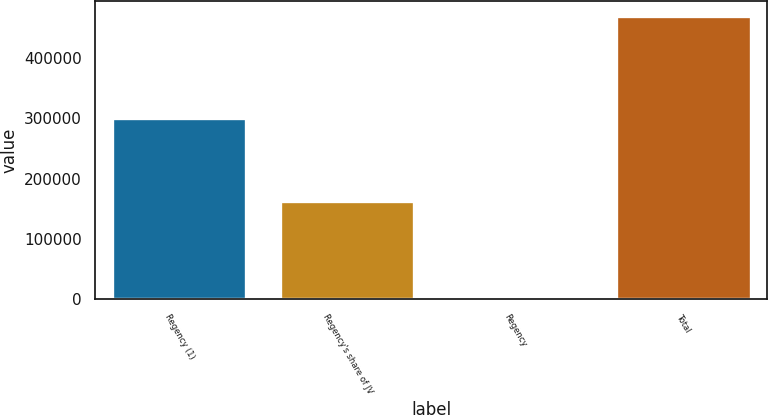Convert chart. <chart><loc_0><loc_0><loc_500><loc_500><bar_chart><fcel>Regency (1)<fcel>Regency's share of JV<fcel>Regency<fcel>Total<nl><fcel>301393<fcel>163854<fcel>4169<fcel>470227<nl></chart> 